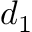<formula> <loc_0><loc_0><loc_500><loc_500>d _ { 1 }</formula> 